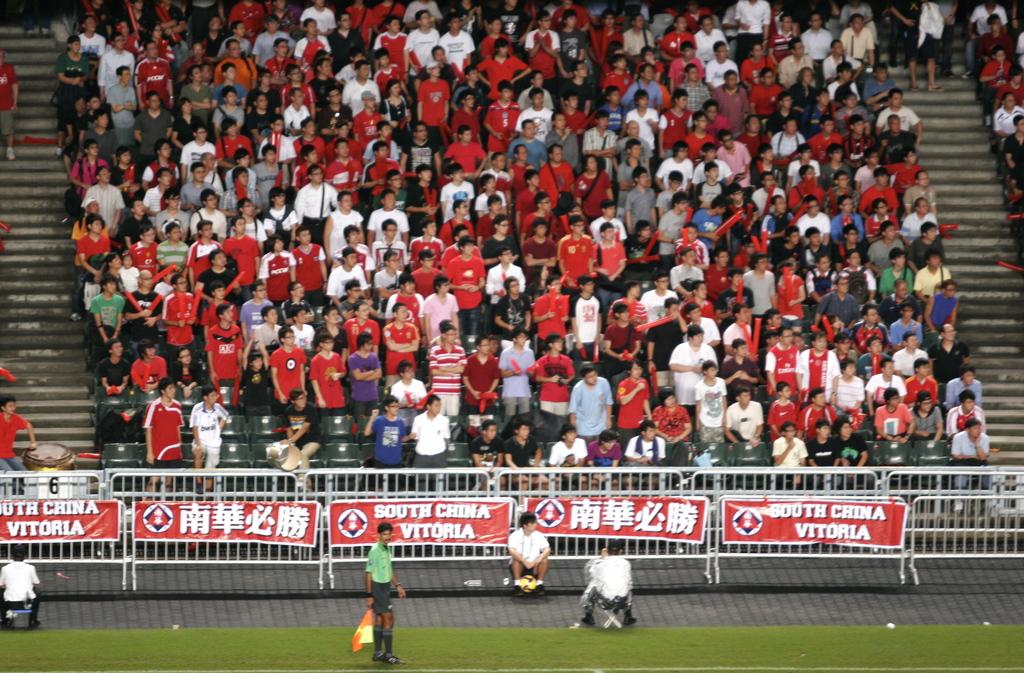What country is likely represented here?
Make the answer very short. China. Is this north or south china?
Offer a terse response. South. 